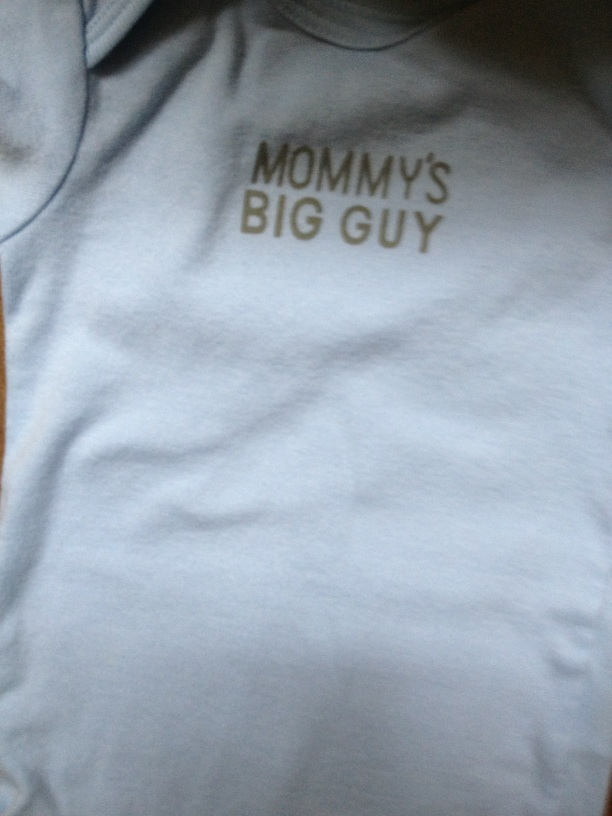Create a short story involving a baby wearing this shirt. Once upon a time, in a cozy little house, there lived a baby named Jack. Jack had a special shirt that read 'Mommy's Big Guy.' Every time he wore it, his mommy would smile and give him a big hug. One sunny afternoon, Jack's family went to the park. As they walked around, everyone noticed Jack's shirt and smiled. 'What a big guy you have!' people would say. Jack giggled and babbled joyfully, feeling the love and attention. That day, Jack's shirt made the world a little brighter for everyone he met. 